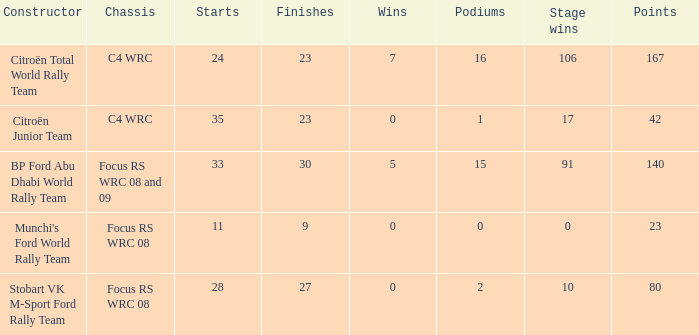What is the highest podiums when the stage wins is 91 and the points is less than 140? None. 